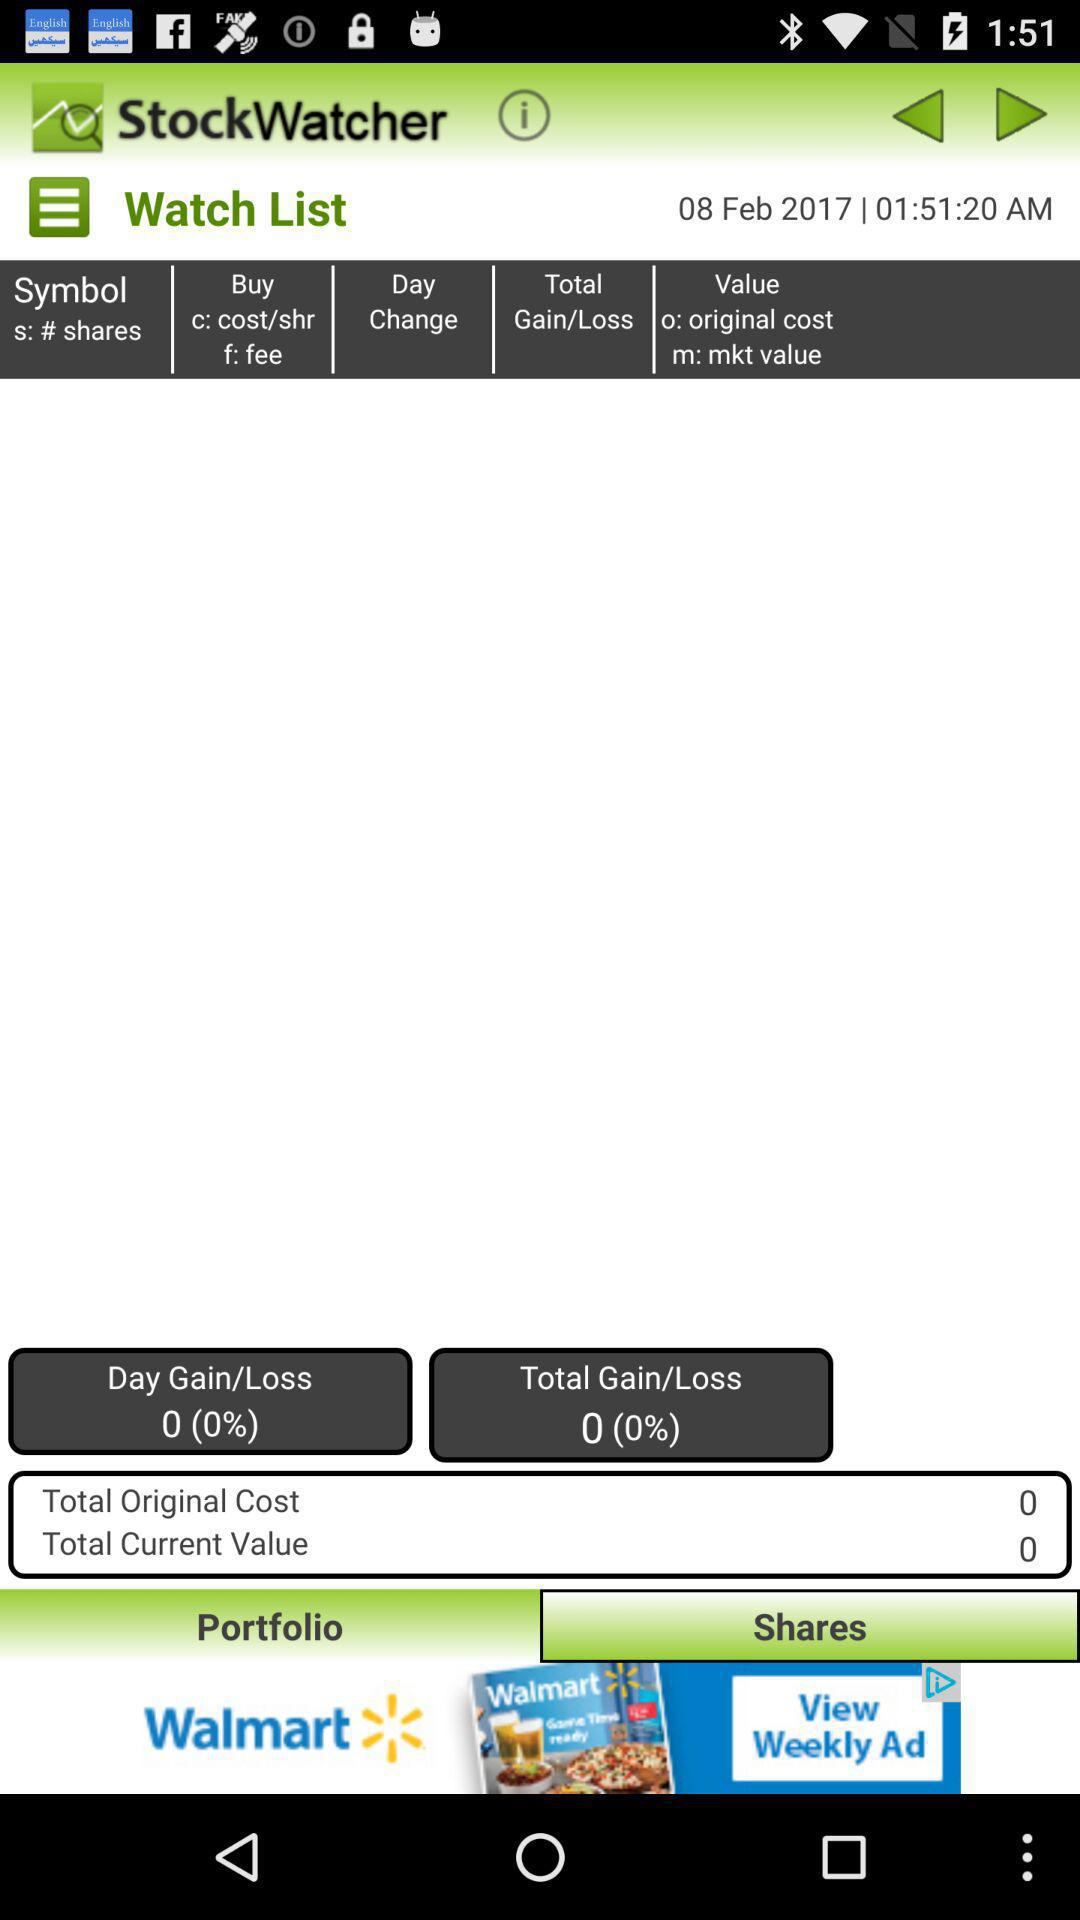What is the total current value? The total current value is 0. 